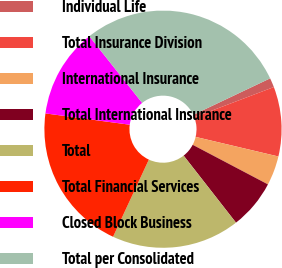Convert chart. <chart><loc_0><loc_0><loc_500><loc_500><pie_chart><fcel>Individual Life<fcel>Total Insurance Division<fcel>International Insurance<fcel>Total International Insurance<fcel>Total<fcel>Total Financial Services<fcel>Closed Block Business<fcel>Total per Consolidated<nl><fcel>1.27%<fcel>9.48%<fcel>4.01%<fcel>6.74%<fcel>17.47%<fcel>20.21%<fcel>12.21%<fcel>28.62%<nl></chart> 